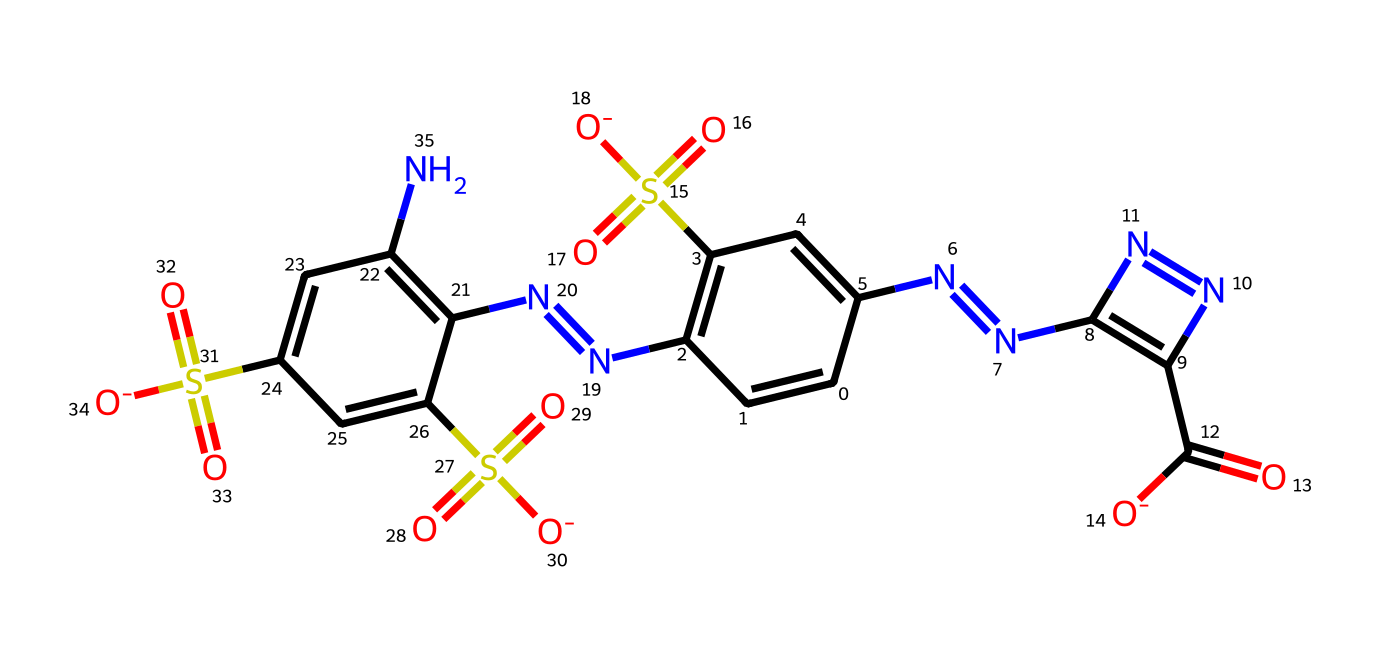what is the main color associated with tartrazine? The chemical structure of tartrazine contains a series of aromatic rings and functional groups that provide its characteristic yellow color.
Answer: yellow how many nitrogen atoms are present in tartrazine? By examining the SMILES representation, we can count the number of nitrogen (N) atoms, which appear four times throughout the structure.
Answer: four what functional group is responsible for the sulfonic acid properties in tartrazine? The structure includes sulfonic acid groups (S(=O)(=O)[O-]), which are characteristic of sulfonic acids and contribute to the compound's solubility and reactivity.
Answer: sulfonic acid what is the significance of the azo bond in tartrazine? The azo bond (N=N) is crucial for the stability and coloration of the dye, contributing to its effectiveness as a food coloring.
Answer: stability and coloration which part of the chemical affects its solubility in water? The sulfonic acid groups (S(=O)(=O)[O-]) present in the structure enhance the solubility of tartrazine in water due to their ionic nature.
Answer: sulfonic acid groups how many rings are in the structure of tartrazine? By evaluating the SMILES representation, we can identify a total of three aromatic rings present in the chemical structure.
Answer: three 